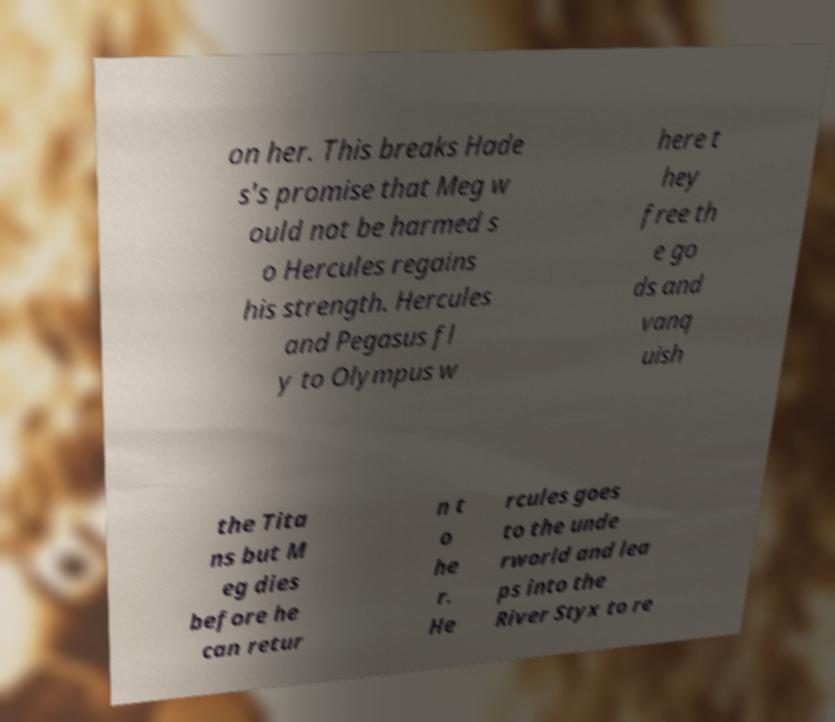Please identify and transcribe the text found in this image. on her. This breaks Hade s's promise that Meg w ould not be harmed s o Hercules regains his strength. Hercules and Pegasus fl y to Olympus w here t hey free th e go ds and vanq uish the Tita ns but M eg dies before he can retur n t o he r. He rcules goes to the unde rworld and lea ps into the River Styx to re 